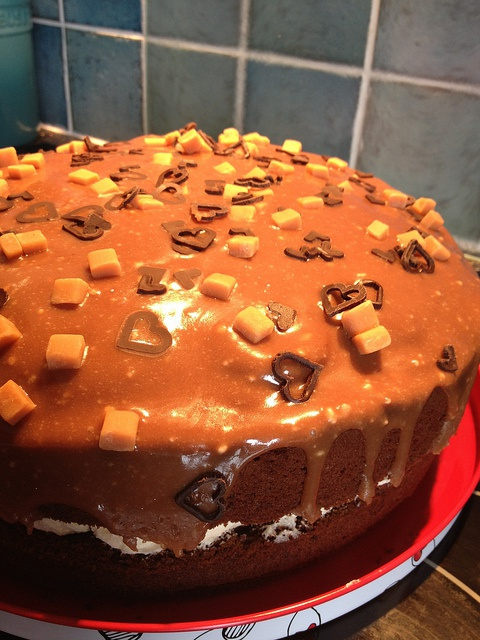Describe the objects in this image and their specific colors. I can see a cake in teal, red, maroon, orange, and black tones in this image. 